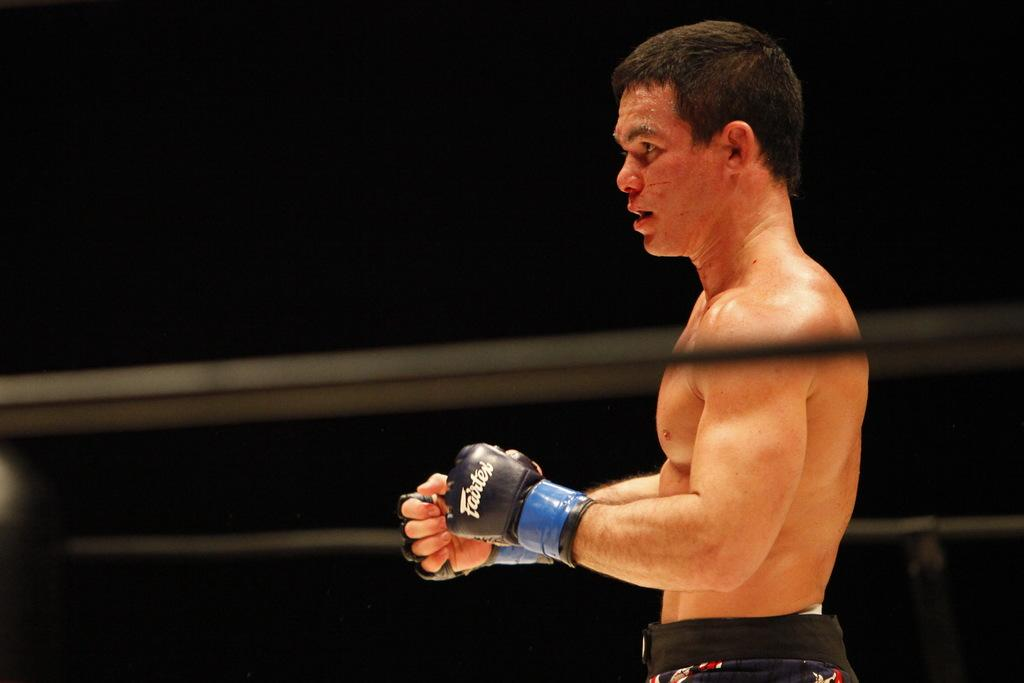Who or what is the main subject of the image? There is a person in the image. What is the person wearing on their hands? The person is wearing black color gloves. Can you describe the background of the image? The background of the image is dark. What type of education system is being discussed in the image? There is no discussion or reference to an education system in the image; it features a person wearing black gloves against a dark background. 